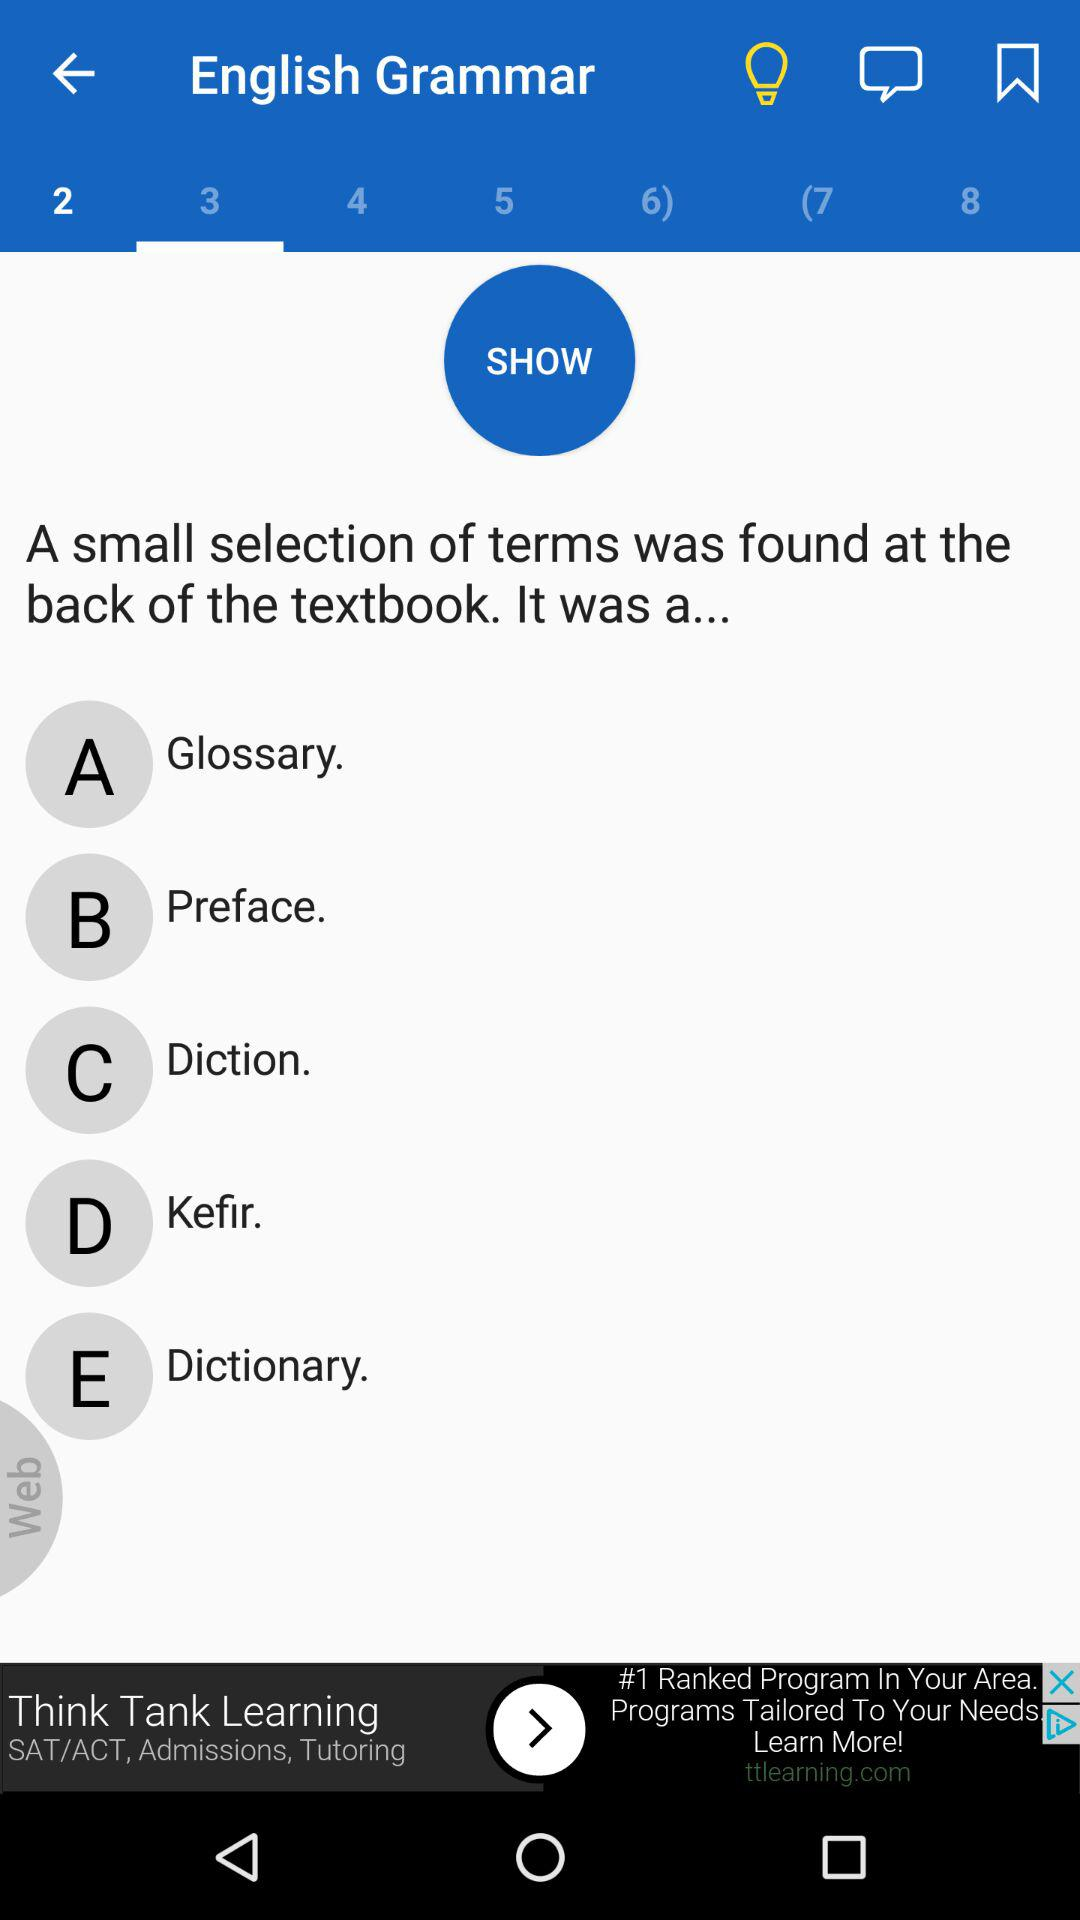Which tab am I using? You are using the "3" tab. 